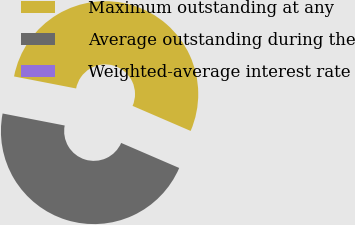<chart> <loc_0><loc_0><loc_500><loc_500><pie_chart><fcel>Maximum outstanding at any<fcel>Average outstanding during the<fcel>Weighted-average interest rate<nl><fcel>53.44%<fcel>46.56%<fcel>0.0%<nl></chart> 